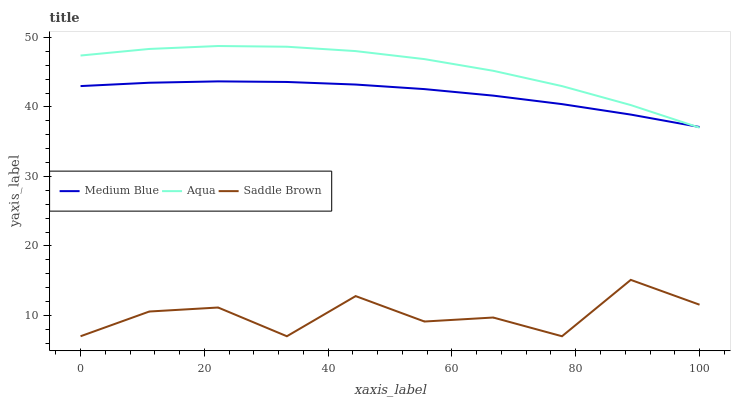Does Saddle Brown have the minimum area under the curve?
Answer yes or no. Yes. Does Aqua have the maximum area under the curve?
Answer yes or no. Yes. Does Medium Blue have the minimum area under the curve?
Answer yes or no. No. Does Medium Blue have the maximum area under the curve?
Answer yes or no. No. Is Medium Blue the smoothest?
Answer yes or no. Yes. Is Saddle Brown the roughest?
Answer yes or no. Yes. Is Saddle Brown the smoothest?
Answer yes or no. No. Is Medium Blue the roughest?
Answer yes or no. No. Does Saddle Brown have the lowest value?
Answer yes or no. Yes. Does Medium Blue have the lowest value?
Answer yes or no. No. Does Aqua have the highest value?
Answer yes or no. Yes. Does Medium Blue have the highest value?
Answer yes or no. No. Is Saddle Brown less than Aqua?
Answer yes or no. Yes. Is Aqua greater than Saddle Brown?
Answer yes or no. Yes. Does Medium Blue intersect Aqua?
Answer yes or no. Yes. Is Medium Blue less than Aqua?
Answer yes or no. No. Is Medium Blue greater than Aqua?
Answer yes or no. No. Does Saddle Brown intersect Aqua?
Answer yes or no. No. 